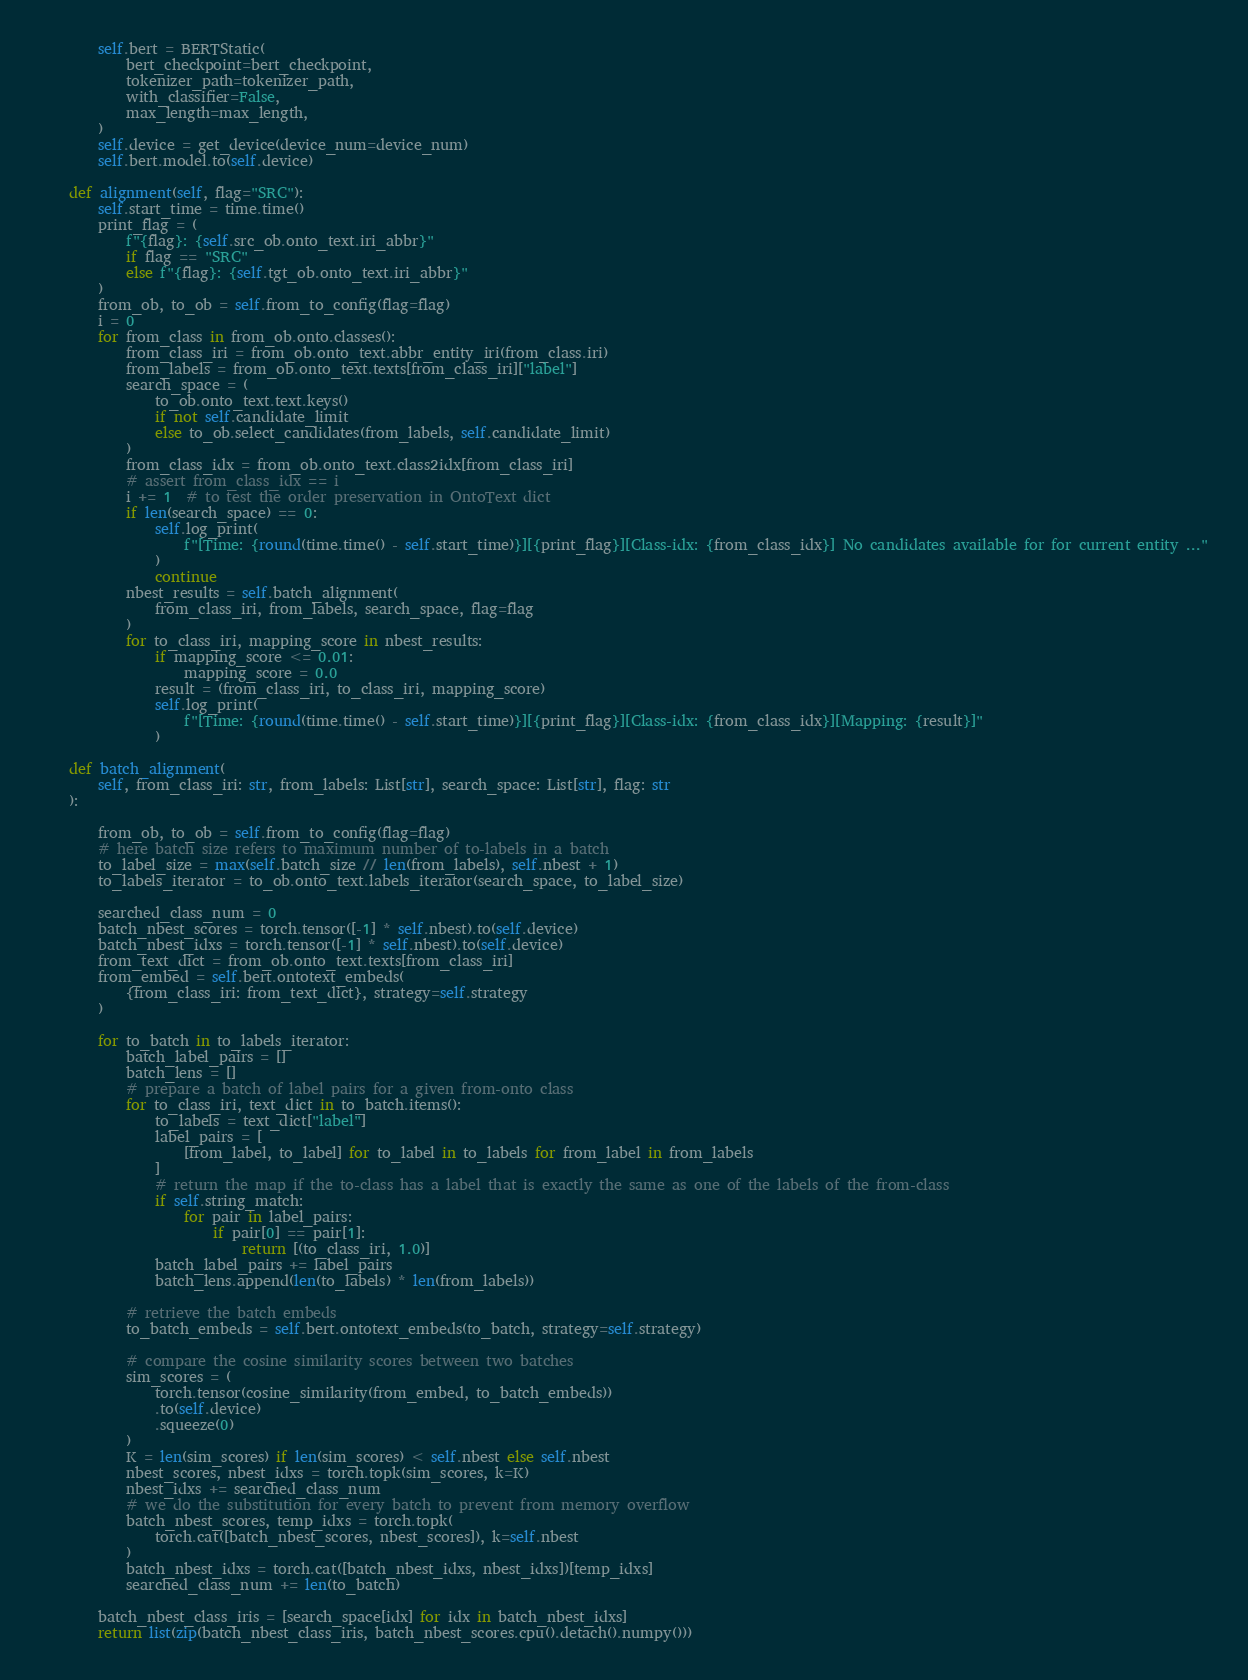Convert code to text. <code><loc_0><loc_0><loc_500><loc_500><_Python_>
        self.bert = BERTStatic(
            bert_checkpoint=bert_checkpoint,
            tokenizer_path=tokenizer_path,
            with_classifier=False,
            max_length=max_length,
        )
        self.device = get_device(device_num=device_num)
        self.bert.model.to(self.device)

    def alignment(self, flag="SRC"):
        self.start_time = time.time()
        print_flag = (
            f"{flag}: {self.src_ob.onto_text.iri_abbr}"
            if flag == "SRC"
            else f"{flag}: {self.tgt_ob.onto_text.iri_abbr}"
        )
        from_ob, to_ob = self.from_to_config(flag=flag)
        i = 0
        for from_class in from_ob.onto.classes():
            from_class_iri = from_ob.onto_text.abbr_entity_iri(from_class.iri)
            from_labels = from_ob.onto_text.texts[from_class_iri]["label"]
            search_space = (
                to_ob.onto_text.text.keys()
                if not self.candidate_limit
                else to_ob.select_candidates(from_labels, self.candidate_limit)
            )
            from_class_idx = from_ob.onto_text.class2idx[from_class_iri]
            # assert from_class_idx == i
            i += 1  # to test the order preservation in OntoText dict
            if len(search_space) == 0:
                self.log_print(
                    f"[Time: {round(time.time() - self.start_time)}][{print_flag}][Class-idx: {from_class_idx}] No candidates available for for current entity ..."
                )
                continue
            nbest_results = self.batch_alignment(
                from_class_iri, from_labels, search_space, flag=flag
            )
            for to_class_iri, mapping_score in nbest_results:
                if mapping_score <= 0.01:
                    mapping_score = 0.0
                result = (from_class_iri, to_class_iri, mapping_score)
                self.log_print(
                    f"[Time: {round(time.time() - self.start_time)}][{print_flag}][Class-idx: {from_class_idx}][Mapping: {result}]"
                )

    def batch_alignment(
        self, from_class_iri: str, from_labels: List[str], search_space: List[str], flag: str
    ):

        from_ob, to_ob = self.from_to_config(flag=flag)
        # here batch size refers to maximum number of to-labels in a batch
        to_label_size = max(self.batch_size // len(from_labels), self.nbest + 1)
        to_labels_iterator = to_ob.onto_text.labels_iterator(search_space, to_label_size)
        
        searched_class_num = 0
        batch_nbest_scores = torch.tensor([-1] * self.nbest).to(self.device)
        batch_nbest_idxs = torch.tensor([-1] * self.nbest).to(self.device)
        from_text_dict = from_ob.onto_text.texts[from_class_iri]
        from_embed = self.bert.ontotext_embeds(
            {from_class_iri: from_text_dict}, strategy=self.strategy
        )

        for to_batch in to_labels_iterator:
            batch_label_pairs = []
            batch_lens = []
            # prepare a batch of label pairs for a given from-onto class
            for to_class_iri, text_dict in to_batch.items():
                to_labels = text_dict["label"]
                label_pairs = [
                    [from_label, to_label] for to_label in to_labels for from_label in from_labels
                ]
                # return the map if the to-class has a label that is exactly the same as one of the labels of the from-class
                if self.string_match:
                    for pair in label_pairs:
                        if pair[0] == pair[1]:
                            return [(to_class_iri, 1.0)]
                batch_label_pairs += label_pairs
                batch_lens.append(len(to_labels) * len(from_labels))

            # retrieve the batch embeds
            to_batch_embeds = self.bert.ontotext_embeds(to_batch, strategy=self.strategy)

            # compare the cosine similarity scores between two batches
            sim_scores = (
                torch.tensor(cosine_similarity(from_embed, to_batch_embeds))
                .to(self.device)
                .squeeze(0)
            )
            K = len(sim_scores) if len(sim_scores) < self.nbest else self.nbest
            nbest_scores, nbest_idxs = torch.topk(sim_scores, k=K)
            nbest_idxs += searched_class_num
            # we do the substitution for every batch to prevent from memory overflow
            batch_nbest_scores, temp_idxs = torch.topk(
                torch.cat([batch_nbest_scores, nbest_scores]), k=self.nbest
            )
            batch_nbest_idxs = torch.cat([batch_nbest_idxs, nbest_idxs])[temp_idxs]
            searched_class_num += len(to_batch)

        batch_nbest_class_iris = [search_space[idx] for idx in batch_nbest_idxs]
        return list(zip(batch_nbest_class_iris, batch_nbest_scores.cpu().detach().numpy()))
</code> 